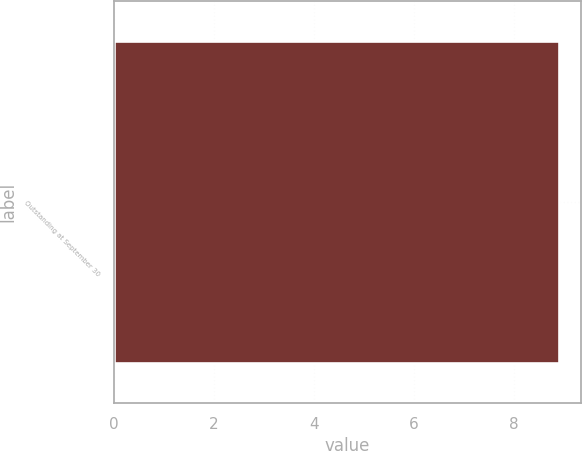Convert chart to OTSL. <chart><loc_0><loc_0><loc_500><loc_500><bar_chart><fcel>Outstanding at September 30<nl><fcel>8.9<nl></chart> 